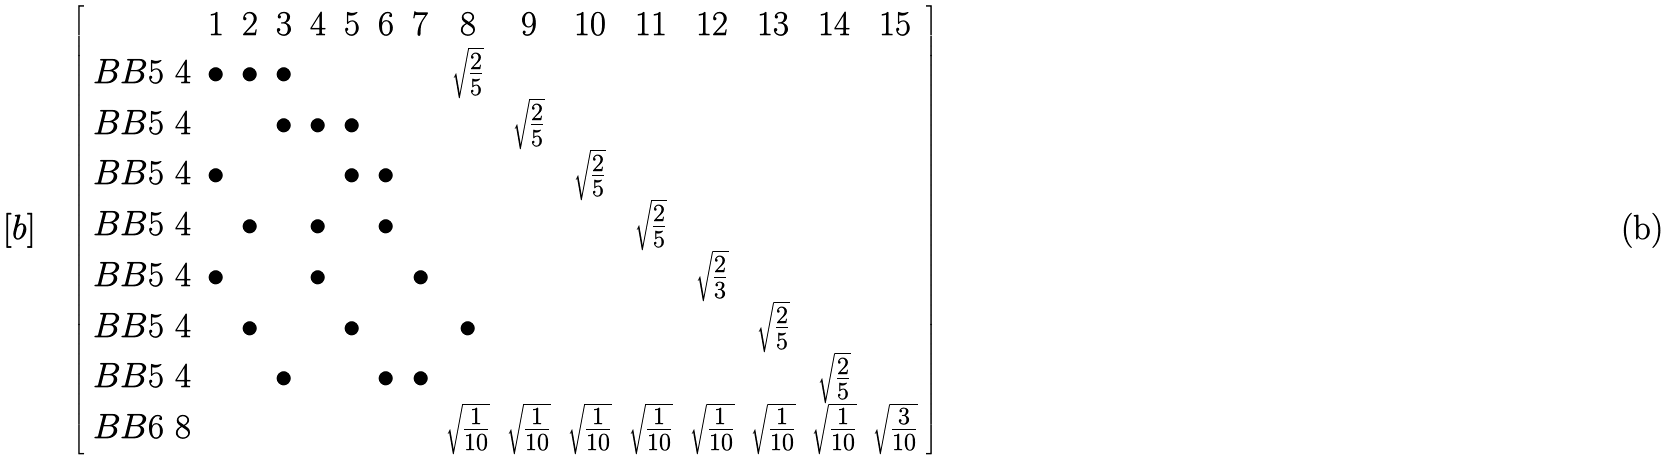<formula> <loc_0><loc_0><loc_500><loc_500>[ b ] & \quad \left [ \begin{array} { c c c c c c c c c c c c c c c c } & 1 & 2 & 3 & 4 & 5 & 6 & 7 & 8 & 9 & 1 0 & 1 1 & 1 2 & 1 3 & 1 4 & 1 5 \\ B B 5 \ 4 & \bullet & \bullet & \bullet & & & & & \sqrt { \frac { 2 } { 5 } } & & & & & & & \\ B B 5 \ 4 & & & \bullet & \bullet & \bullet & & & & \sqrt { \frac { 2 } { 5 } } & & & & & & \\ B B 5 \ 4 & \bullet & & & & \bullet & \bullet & & & & \sqrt { \frac { 2 } { 5 } } & & & & & \\ B B 5 \ 4 & & \bullet & & \bullet & & \bullet & & & & & \sqrt { \frac { 2 } { 5 } } & & & & \\ B B 5 \ 4 & \bullet & & & \bullet & & & \bullet & & & & & \sqrt { \frac { 2 } { 3 } } & & & \\ B B 5 \ 4 & & \bullet & & & \bullet & & & \bullet & & & & & \sqrt { \frac { 2 } { 5 } } & & \\ B B 5 \ 4 & & & \bullet & & & \bullet & \bullet & & & & & & & \sqrt { \frac { 2 } { 5 } } & \\ B B 6 \ 8 & & & & & & & & \sqrt { \frac { 1 } { 1 0 } } & \sqrt { \frac { 1 } { 1 0 } } & \sqrt { \frac { 1 } { 1 0 } } & \sqrt { \frac { 1 } { 1 0 } } & \sqrt { \frac { 1 } { 1 0 } } & \sqrt { \frac { 1 } { 1 0 } } & \sqrt { \frac { 1 } { 1 0 } } & \sqrt { \frac { 3 } { 1 0 } } \\ \end{array} \right ]</formula> 